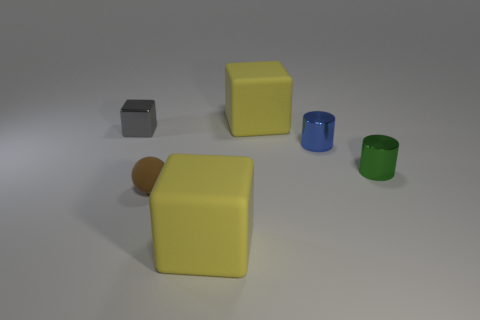Are there more tiny green shiny cylinders than big yellow cubes?
Your answer should be very brief. No. Is the number of large objects that are in front of the small gray metal object greater than the number of metal objects that are in front of the tiny brown matte ball?
Your answer should be compact. Yes. How big is the block that is right of the small shiny block and behind the tiny blue object?
Your answer should be compact. Large. How many cyan shiny cylinders have the same size as the gray block?
Ensure brevity in your answer.  0. Does the yellow thing in front of the green cylinder have the same shape as the gray shiny thing?
Make the answer very short. Yes. Are there fewer tiny green objects behind the metal block than small shiny cubes?
Your answer should be very brief. Yes. Do the blue thing and the metallic object in front of the tiny blue shiny thing have the same shape?
Keep it short and to the point. Yes. Are there any big objects that have the same material as the tiny brown thing?
Your response must be concise. Yes. Is there a yellow object that is to the right of the large yellow object in front of the rubber thing that is behind the gray metal object?
Make the answer very short. Yes. What number of other things are the same shape as the tiny brown thing?
Keep it short and to the point. 0. 